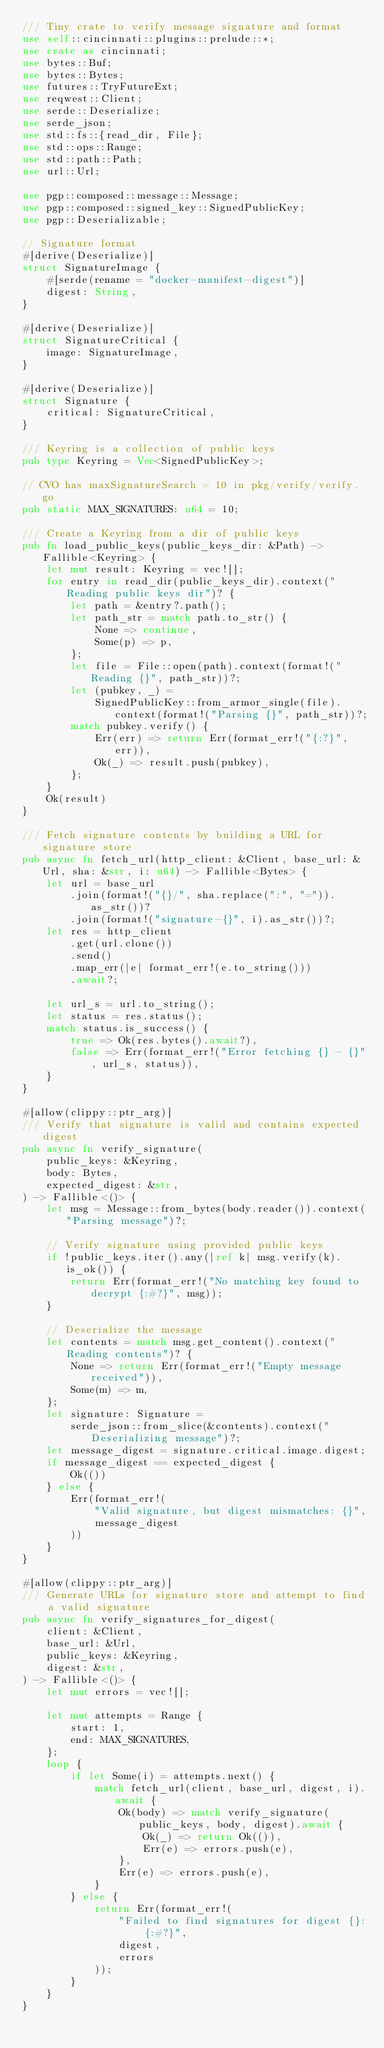Convert code to text. <code><loc_0><loc_0><loc_500><loc_500><_Rust_>/// Tiny crate to verify message signature and format
use self::cincinnati::plugins::prelude::*;
use crate as cincinnati;
use bytes::Buf;
use bytes::Bytes;
use futures::TryFutureExt;
use reqwest::Client;
use serde::Deserialize;
use serde_json;
use std::fs::{read_dir, File};
use std::ops::Range;
use std::path::Path;
use url::Url;

use pgp::composed::message::Message;
use pgp::composed::signed_key::SignedPublicKey;
use pgp::Deserializable;

// Signature format
#[derive(Deserialize)]
struct SignatureImage {
    #[serde(rename = "docker-manifest-digest")]
    digest: String,
}

#[derive(Deserialize)]
struct SignatureCritical {
    image: SignatureImage,
}

#[derive(Deserialize)]
struct Signature {
    critical: SignatureCritical,
}

/// Keyring is a collection of public keys
pub type Keyring = Vec<SignedPublicKey>;

// CVO has maxSignatureSearch = 10 in pkg/verify/verify.go
pub static MAX_SIGNATURES: u64 = 10;

/// Create a Keyring from a dir of public keys
pub fn load_public_keys(public_keys_dir: &Path) -> Fallible<Keyring> {
    let mut result: Keyring = vec![];
    for entry in read_dir(public_keys_dir).context("Reading public keys dir")? {
        let path = &entry?.path();
        let path_str = match path.to_str() {
            None => continue,
            Some(p) => p,
        };
        let file = File::open(path).context(format!("Reading {}", path_str))?;
        let (pubkey, _) =
            SignedPublicKey::from_armor_single(file).context(format!("Parsing {}", path_str))?;
        match pubkey.verify() {
            Err(err) => return Err(format_err!("{:?}", err)),
            Ok(_) => result.push(pubkey),
        };
    }
    Ok(result)
}

/// Fetch signature contents by building a URL for signature store
pub async fn fetch_url(http_client: &Client, base_url: &Url, sha: &str, i: u64) -> Fallible<Bytes> {
    let url = base_url
        .join(format!("{}/", sha.replace(":", "=")).as_str())?
        .join(format!("signature-{}", i).as_str())?;
    let res = http_client
        .get(url.clone())
        .send()
        .map_err(|e| format_err!(e.to_string()))
        .await?;

    let url_s = url.to_string();
    let status = res.status();
    match status.is_success() {
        true => Ok(res.bytes().await?),
        false => Err(format_err!("Error fetching {} - {}", url_s, status)),
    }
}

#[allow(clippy::ptr_arg)]
/// Verify that signature is valid and contains expected digest
pub async fn verify_signature(
    public_keys: &Keyring,
    body: Bytes,
    expected_digest: &str,
) -> Fallible<()> {
    let msg = Message::from_bytes(body.reader()).context("Parsing message")?;

    // Verify signature using provided public keys
    if !public_keys.iter().any(|ref k| msg.verify(k).is_ok()) {
        return Err(format_err!("No matching key found to decrypt {:#?}", msg));
    }

    // Deserialize the message
    let contents = match msg.get_content().context("Reading contents")? {
        None => return Err(format_err!("Empty message received")),
        Some(m) => m,
    };
    let signature: Signature =
        serde_json::from_slice(&contents).context("Deserializing message")?;
    let message_digest = signature.critical.image.digest;
    if message_digest == expected_digest {
        Ok(())
    } else {
        Err(format_err!(
            "Valid signature, but digest mismatches: {}",
            message_digest
        ))
    }
}

#[allow(clippy::ptr_arg)]
/// Generate URLs for signature store and attempt to find a valid signature
pub async fn verify_signatures_for_digest(
    client: &Client,
    base_url: &Url,
    public_keys: &Keyring,
    digest: &str,
) -> Fallible<()> {
    let mut errors = vec![];

    let mut attempts = Range {
        start: 1,
        end: MAX_SIGNATURES,
    };
    loop {
        if let Some(i) = attempts.next() {
            match fetch_url(client, base_url, digest, i).await {
                Ok(body) => match verify_signature(public_keys, body, digest).await {
                    Ok(_) => return Ok(()),
                    Err(e) => errors.push(e),
                },
                Err(e) => errors.push(e),
            }
        } else {
            return Err(format_err!(
                "Failed to find signatures for digest {}: {:#?}",
                digest,
                errors
            ));
        }
    }
}
</code> 